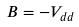<formula> <loc_0><loc_0><loc_500><loc_500>B = - V _ { d d }</formula> 